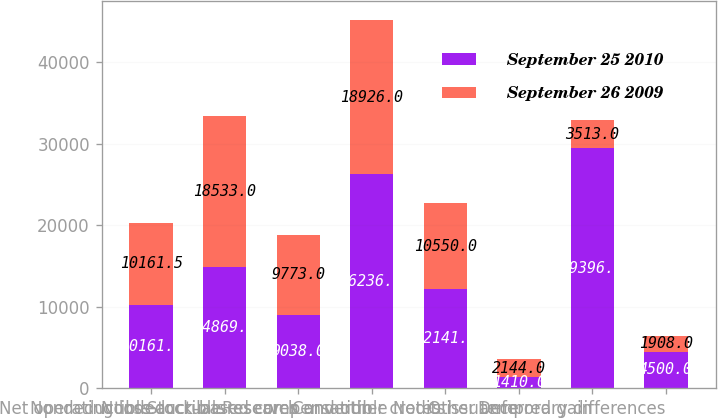Convert chart to OTSL. <chart><loc_0><loc_0><loc_500><loc_500><stacked_bar_chart><ecel><fcel>Net operating loss<fcel>Nondeductible accruals<fcel>Nondeductible reserves<fcel>Stock-based compensation<fcel>Research and other credits<fcel>Convertible Notes issuance<fcel>Deferred gain<fcel>Other temporary differences<nl><fcel>September 25 2010<fcel>10161.5<fcel>14869<fcel>9038<fcel>26236<fcel>12141<fcel>1410<fcel>29396<fcel>4500<nl><fcel>September 26 2009<fcel>10161.5<fcel>18533<fcel>9773<fcel>18926<fcel>10550<fcel>2144<fcel>3513<fcel>1908<nl></chart> 